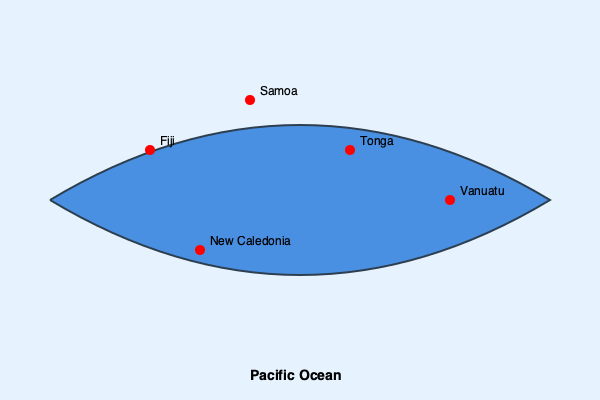Based on the map of the Pacific Ocean shown, which island nation is located furthest to the west? To determine which island nation is located furthest to the west on this map, we need to follow these steps:

1. Understand map orientation: In standard map projections, west is typically on the left side of the map.

2. Identify the nations: The map shows five Pacific Island nations: Fiji, Samoa, Tonga, Vanuatu, and New Caledonia.

3. Compare horizontal positions:
   - Fiji is positioned on the left side of the map.
   - Samoa is located towards the upper middle.
   - Tonga is in the upper right quadrant.
   - Vanuatu is on the far right side.
   - New Caledonia is in the lower middle area.

4. Determine the westernmost point: Among these nations, Vanuatu is positioned furthest to the right on the map.

5. Conclude: Since Vanuatu is the rightmost point on this stylized map of the Pacific, it represents the westernmost nation among the options given.

It's important to note that this is a simplified representation, and in reality, the precise positioning of these nations may vary. However, based on the information provided in this specific map, Vanuatu is depicted as the westernmost nation.
Answer: Vanuatu 